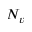<formula> <loc_0><loc_0><loc_500><loc_500>N _ { v }</formula> 